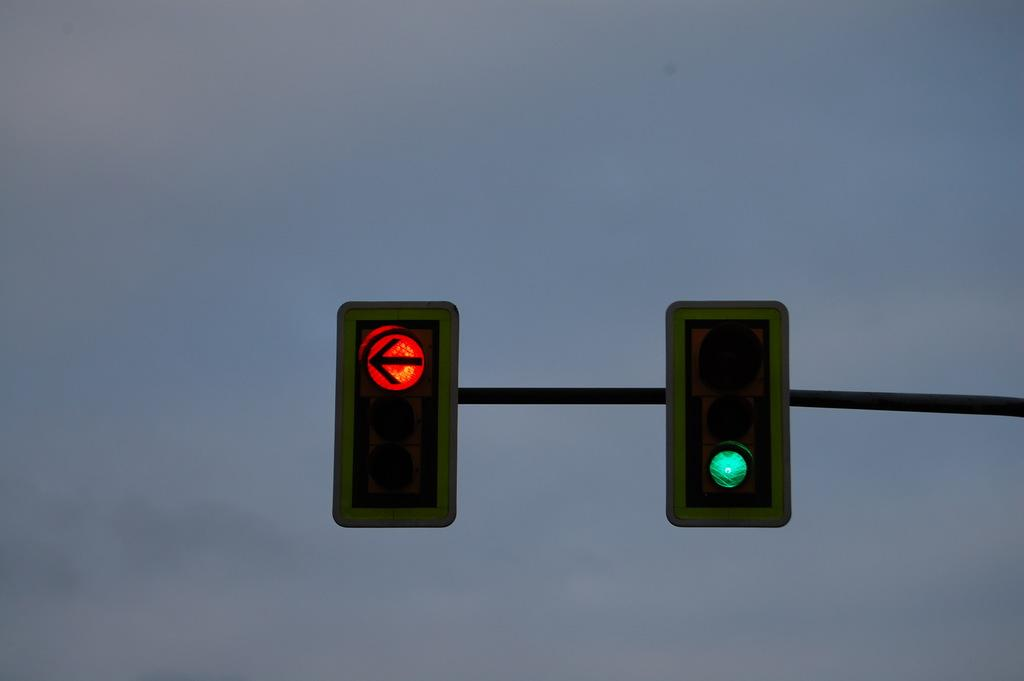What is attached to the pole in the image? There is a pole with traffic signals in the image. What can be seen behind the pole in the image? There is sky visible behind the pole. What type of club is being used to fold the shoes in the image? There is no club or shoes present in the image; it only features a pole with traffic signals and sky in the background. 